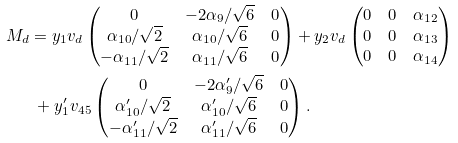Convert formula to latex. <formula><loc_0><loc_0><loc_500><loc_500>M _ { d } & = y _ { 1 } v _ { d } \begin{pmatrix} 0 & - 2 \alpha _ { 9 } / \sqrt { 6 } & 0 \\ \alpha _ { 1 0 } / \sqrt { 2 } & \alpha _ { 1 0 } / \sqrt { 6 } & 0 \\ - \alpha _ { 1 1 } / \sqrt { 2 } & \alpha _ { 1 1 } / \sqrt { 6 } & 0 \end{pmatrix} + y _ { 2 } v _ { d } \begin{pmatrix} 0 & 0 & \alpha _ { 1 2 } \\ 0 & 0 & \alpha _ { 1 3 } \\ 0 & 0 & \alpha _ { 1 4 } \end{pmatrix} \\ & \ + y _ { 1 } ^ { \prime } v _ { 4 5 } \begin{pmatrix} 0 & - 2 \alpha _ { 9 } ^ { \prime } / \sqrt { 6 } & 0 \\ \alpha _ { 1 0 } ^ { \prime } / \sqrt { 2 } & \alpha _ { 1 0 } ^ { \prime } / \sqrt { 6 } & 0 \\ - \alpha _ { 1 1 } ^ { \prime } / \sqrt { 2 } & \alpha _ { 1 1 } ^ { \prime } / \sqrt { 6 } & 0 \end{pmatrix} .</formula> 